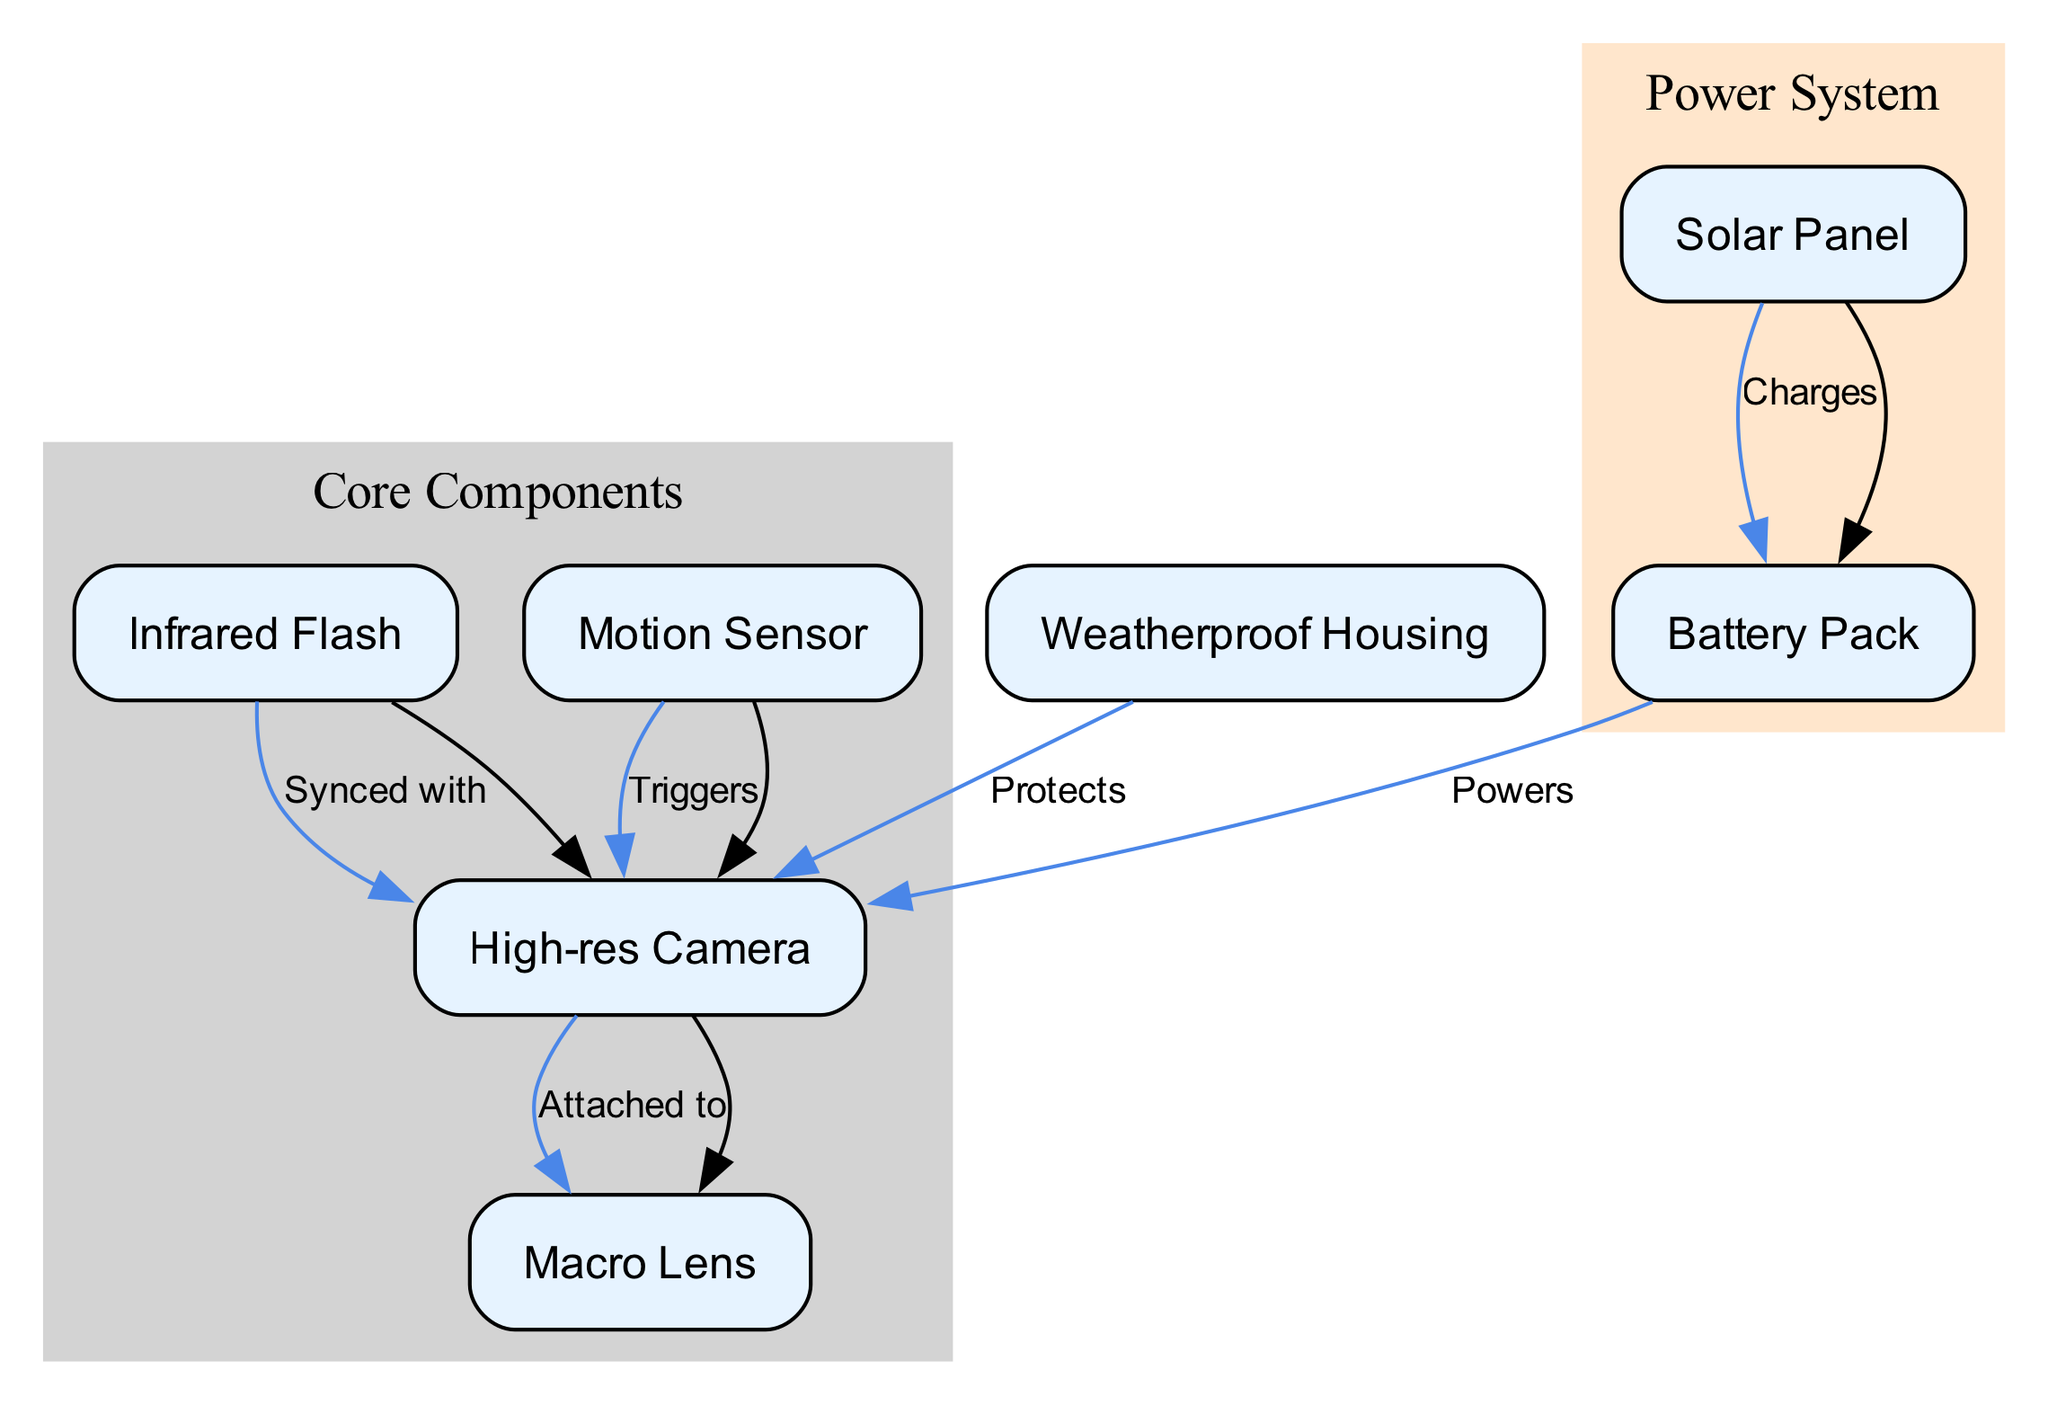What are the main components in the camera trap setup? The diagram lists several nodes, among which the primary components are the High-res Camera, Infrared Flash, Motion Sensor, Weatherproof Housing, Solar Panel, Battery Pack, and Macro Lens.
Answer: High-res Camera, Infrared Flash, Motion Sensor, Weatherproof Housing, Solar Panel, Battery Pack, Macro Lens Which component is responsible for triggering the camera? The diagram indicates that the Motion Sensor triggers the High-res Camera, evidenced by the edge labeled "Triggers" connecting these two nodes.
Answer: Motion Sensor How many nodes are present in the diagram? By counting the number of distinct nodes listed in the diagram, we find there are seven nodes in total: High-res Camera, Infrared Flash, Motion Sensor, Weatherproof Housing, Solar Panel, Battery Pack, and Macro Lens.
Answer: Seven What does the Weatherproof Housing do? According to the diagram, the Weatherproof Housing is indicated to protect the High-res Camera, which is established through the edge labeled "Protects" connecting these nodes.
Answer: Protects Which component powers the High-res Camera? The diagram shows that the Battery Pack powers the High-res Camera, highlighted by the edge labeled "Powers" from the Battery Pack to the High-res Camera.
Answer: Battery Pack How does the Solar Panel contribute to the system? The diagram states that the Solar Panel charges the Battery Pack, illustrated by the edge labeled "Charges" between these two nodes, which allows for energy supply to the system.
Answer: Charges What component is synced with the Infrared Flash? The edge labeled "Synced with" indicates that the Infrared Flash is synchronized with the High-res Camera, demonstrating their interdependent relationship in the operation of the camera trap setup.
Answer: High-res Camera How many edges are used to connect the components? By analyzing the connections represented as edges in the diagram, we observe that there are six edges connecting the different nodes. This indicates the relationships and interactions between components.
Answer: Six What type of lens is used in the camera trap? The diagram specifically denotes the use of a Macro Lens attached to the High-res Camera, thereby highlighting its role in close-up photography of insects.
Answer: Macro Lens 